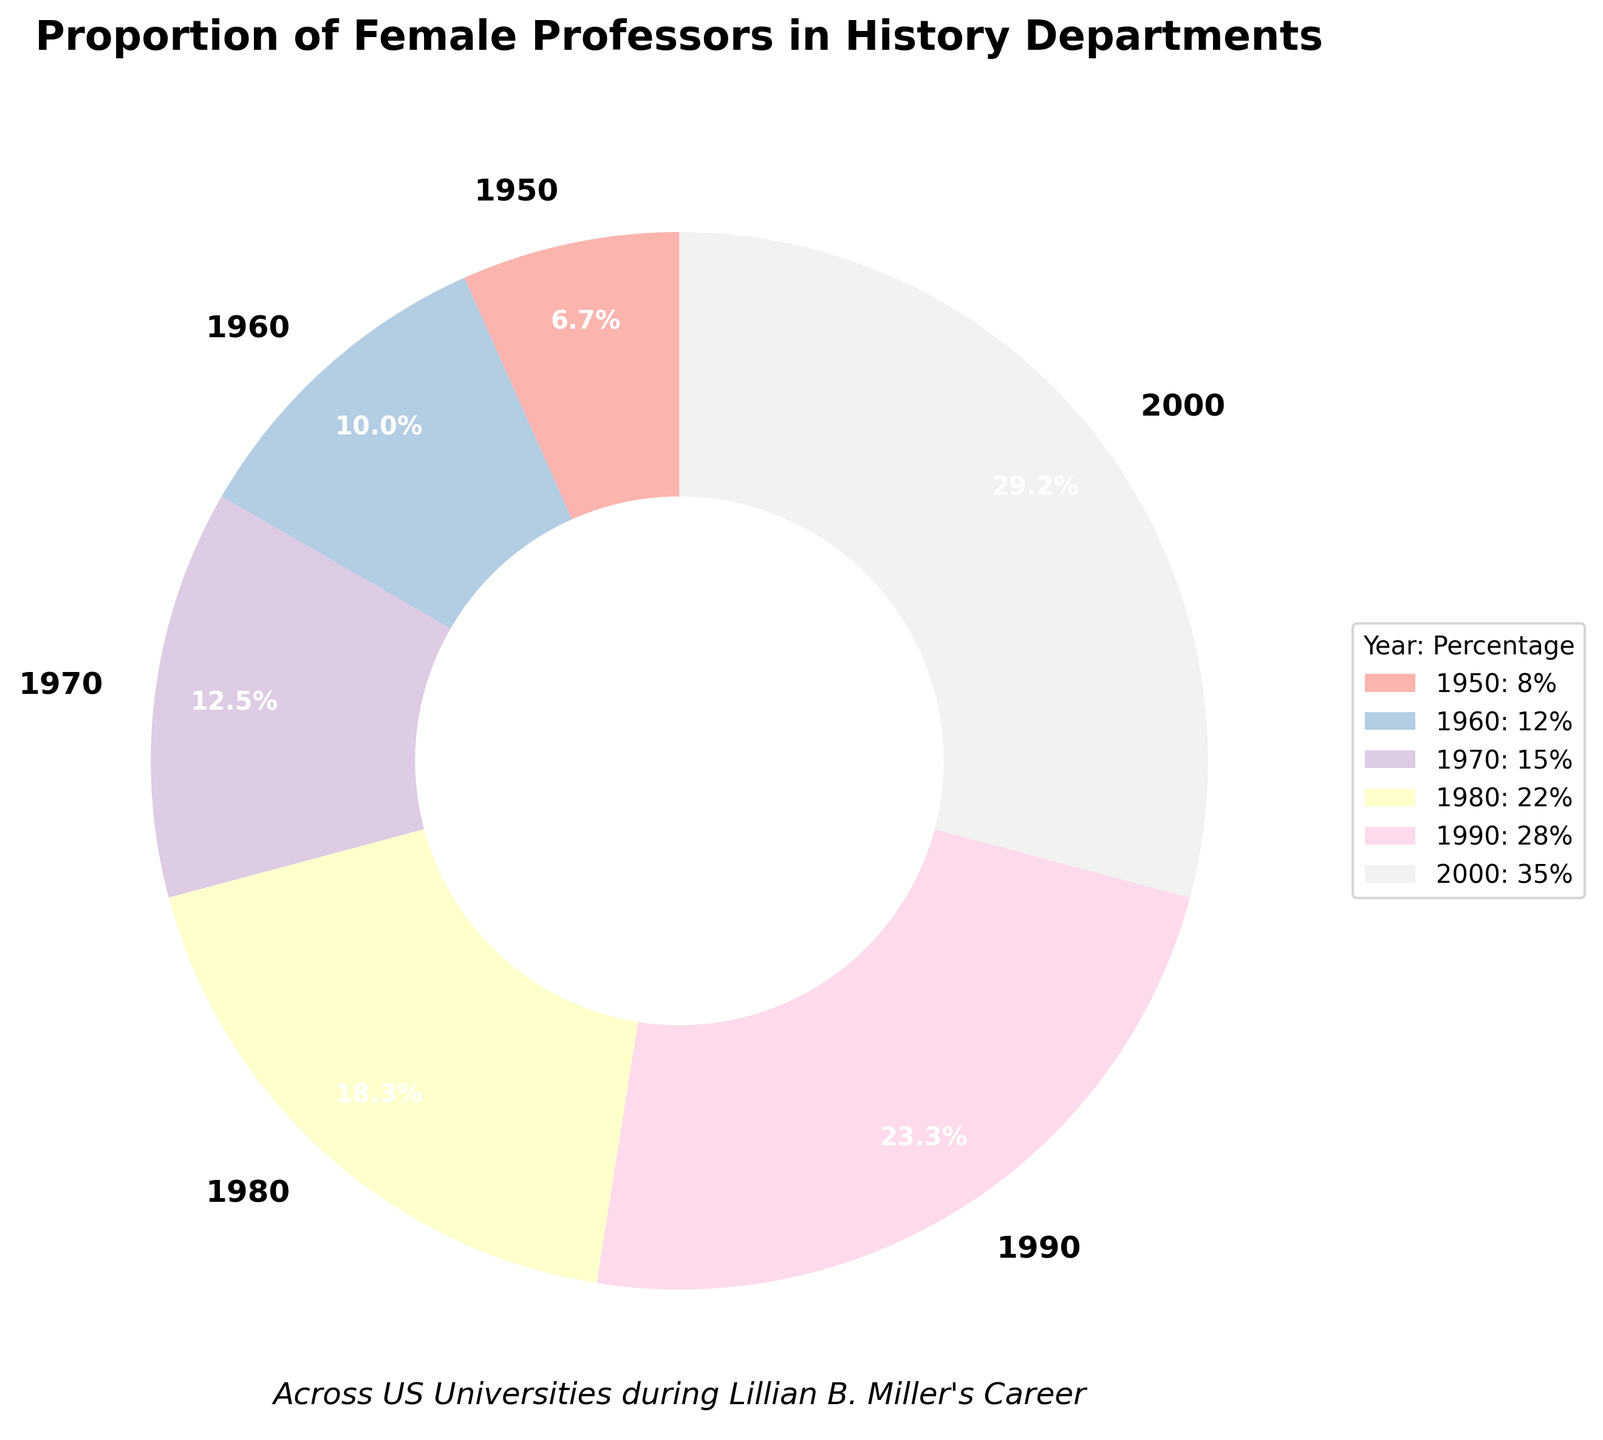What was the percentage of female professors in history departments in 1950? The figure shows the proportion of female professors in different years. For 1950, the slice labeled "1950" shows 8%.
Answer: 8% Which year had a higher percentage of female professors in history departments, 1960 or 2000? By comparing the slices labeled "1960" and "2000", you can see that 2000 has a larger slice with a 35% label, whereas 1960 has a smaller slice labeled 12%.
Answer: 2000 What is the sum of the percentages of female professors in history departments for the years 1980 and 1990? The figure shows the slices with the respective percentages. Adding 22% (1980) and 28% (1990) gives a total of 50%.
Answer: 50% How did the percentage of female professors change from 1950 to 2000? To find the change, subtract the percentage of female professors in 1950 (8%) from that in 2000 (35%). The difference is 35% - 8% = 27%.
Answer: 27% Which year shows the lowest proportion of female professors in history departments? By visually inspecting the sizes of the slices, the smallest slice corresponds to the year 1950, labeled 8%.
Answer: 1950 What is the difference in the percentage of female professors between 1970 and 1980? Subtract the percentage in 1970 (15%) from the percentage in 1980 (22%). The difference is 22% - 15% = 7%.
Answer: 7% Which color represents the year 1990? The color corresponding to the year "1990" slice in the pie chart should be identified. By matching the color legend, it represents one of the pastel colors used. Verifying this visually gives the correct pastel shade (specific shade identification requires the actual chart).
Answer: Pastel shade (Please match with actual chart) During Lillian B. Miller's career, in which decade did the proportion of female professors see the largest increase? Compare the percentage increases between consecutive decades. The increases are: 1950-1960: 4%, 1960-1970: 3%, 1970-1980: 7%, 1980-1990: 6%, 1990-2000: 7%. The largest increase occurred between 1970 and 1980, as well as between 1990 and 2000, both with 7%.
Answer: 1970-1980 and 1990-2000 What is the average percentage of female professors in history departments across all the years shown? Sum all the percentages (8 + 12 + 15 + 22 + 28 + 35 = 120) and divide by the number of years (6). The average is 120 / 6 = 20%.
Answer: 20% 